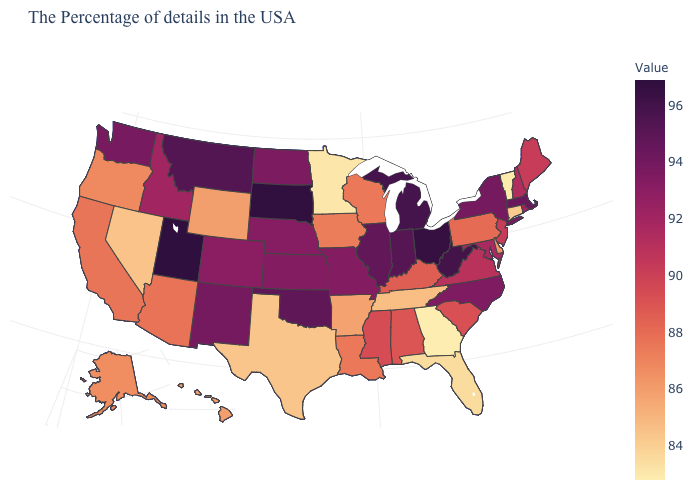Among the states that border Rhode Island , does Massachusetts have the highest value?
Write a very short answer. Yes. Is the legend a continuous bar?
Concise answer only. Yes. Which states have the lowest value in the USA?
Be succinct. Georgia. Does Kansas have the highest value in the USA?
Short answer required. No. Which states have the highest value in the USA?
Keep it brief. Utah. Does Louisiana have the highest value in the South?
Write a very short answer. No. 